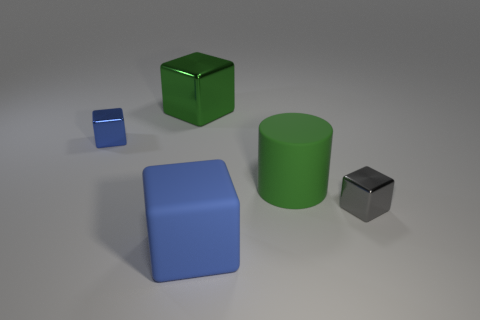What is the size of the block that is the same color as the cylinder?
Keep it short and to the point. Large. There is another block that is the same size as the blue rubber block; what is its color?
Make the answer very short. Green. Is the number of tiny gray metal blocks that are to the left of the green metallic cube less than the number of shiny cubes to the right of the small gray metallic thing?
Your answer should be compact. No. What is the shape of the green object that is behind the tiny blue object behind the big green thing that is in front of the blue shiny thing?
Your answer should be very brief. Cube. There is a rubber thing in front of the small gray block; is it the same color as the small metal thing that is to the left of the large blue rubber block?
Give a very brief answer. Yes. There is a large thing that is the same color as the large cylinder; what is its shape?
Provide a short and direct response. Cube. What number of rubber objects are either small blue cylinders or blue blocks?
Your response must be concise. 1. There is a metal cube that is on the right side of the blue cube in front of the metal block in front of the big green cylinder; what is its color?
Provide a short and direct response. Gray. What is the color of the large metal object that is the same shape as the blue matte thing?
Provide a succinct answer. Green. Is there anything else of the same color as the big matte block?
Give a very brief answer. Yes. 